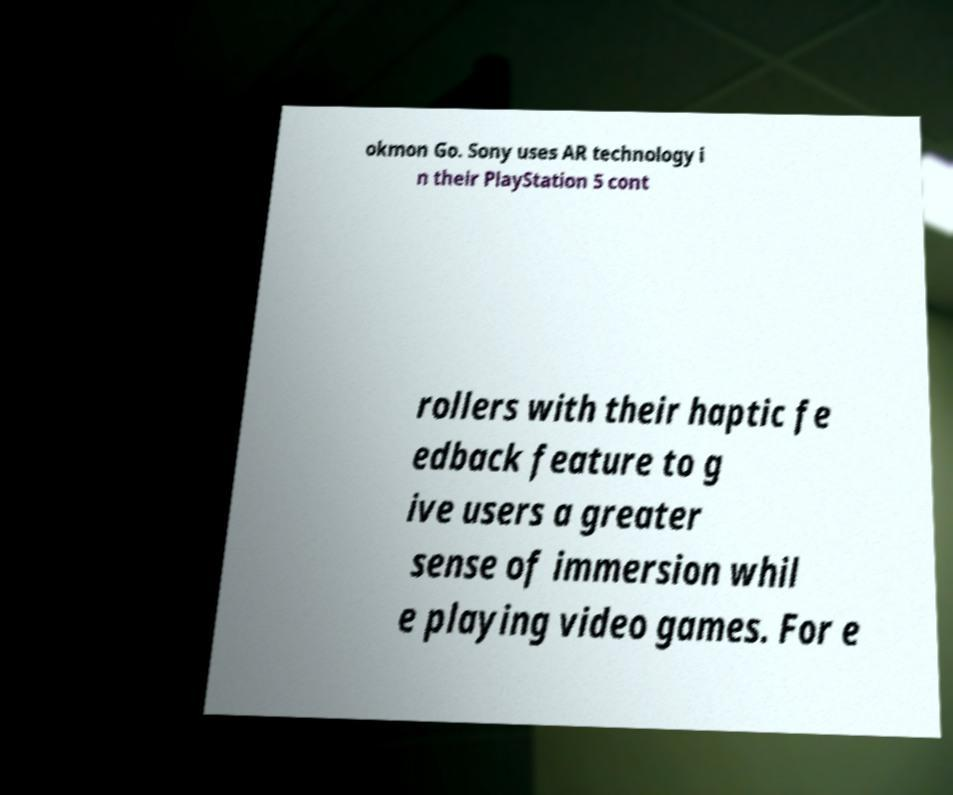For documentation purposes, I need the text within this image transcribed. Could you provide that? okmon Go. Sony uses AR technology i n their PlayStation 5 cont rollers with their haptic fe edback feature to g ive users a greater sense of immersion whil e playing video games. For e 